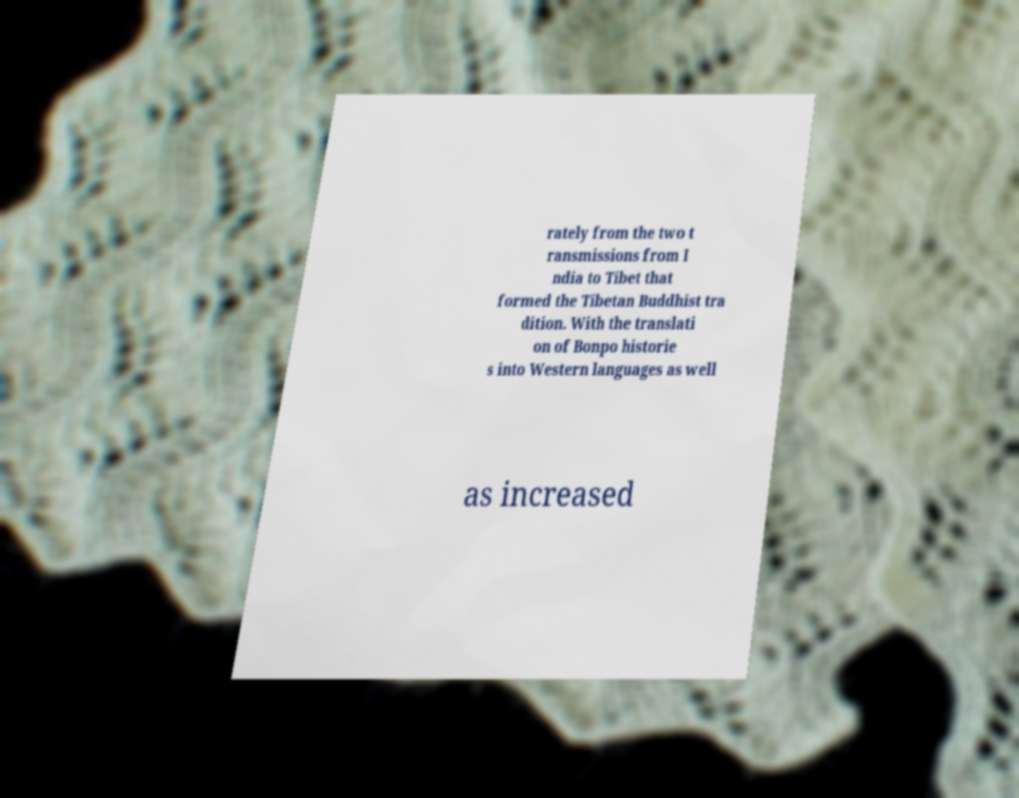Please read and relay the text visible in this image. What does it say? rately from the two t ransmissions from I ndia to Tibet that formed the Tibetan Buddhist tra dition. With the translati on of Bonpo historie s into Western languages as well as increased 